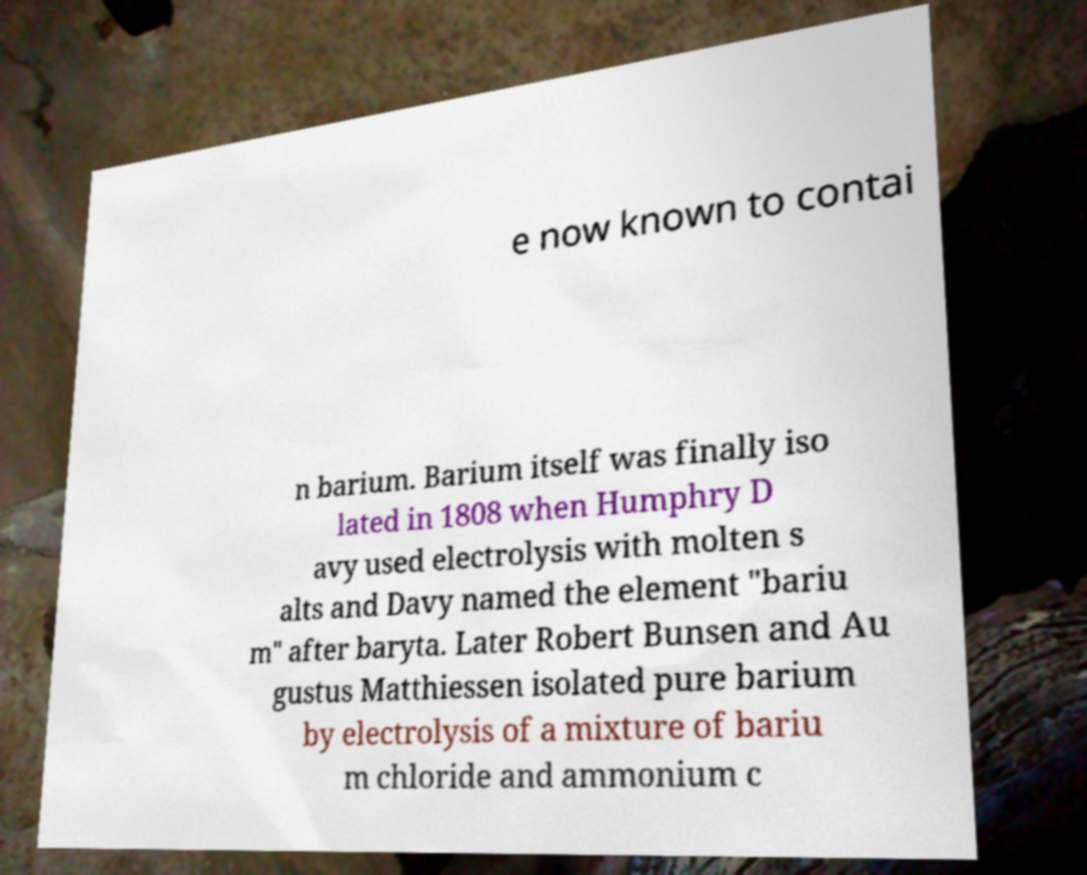Could you assist in decoding the text presented in this image and type it out clearly? e now known to contai n barium. Barium itself was finally iso lated in 1808 when Humphry D avy used electrolysis with molten s alts and Davy named the element "bariu m" after baryta. Later Robert Bunsen and Au gustus Matthiessen isolated pure barium by electrolysis of a mixture of bariu m chloride and ammonium c 